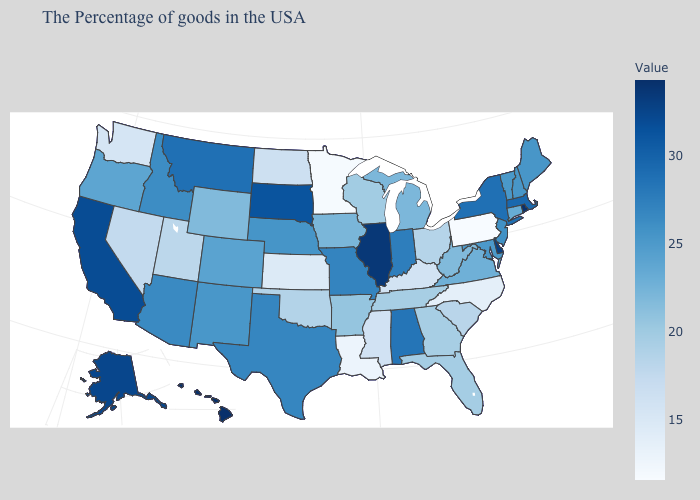Among the states that border New Hampshire , does Massachusetts have the highest value?
Give a very brief answer. Yes. Which states have the lowest value in the USA?
Answer briefly. Pennsylvania. Among the states that border Kansas , does Missouri have the highest value?
Give a very brief answer. Yes. Does the map have missing data?
Write a very short answer. No. Among the states that border Virginia , which have the highest value?
Short answer required. Maryland. Among the states that border Arizona , which have the highest value?
Be succinct. California. Which states have the highest value in the USA?
Keep it brief. Hawaii. 